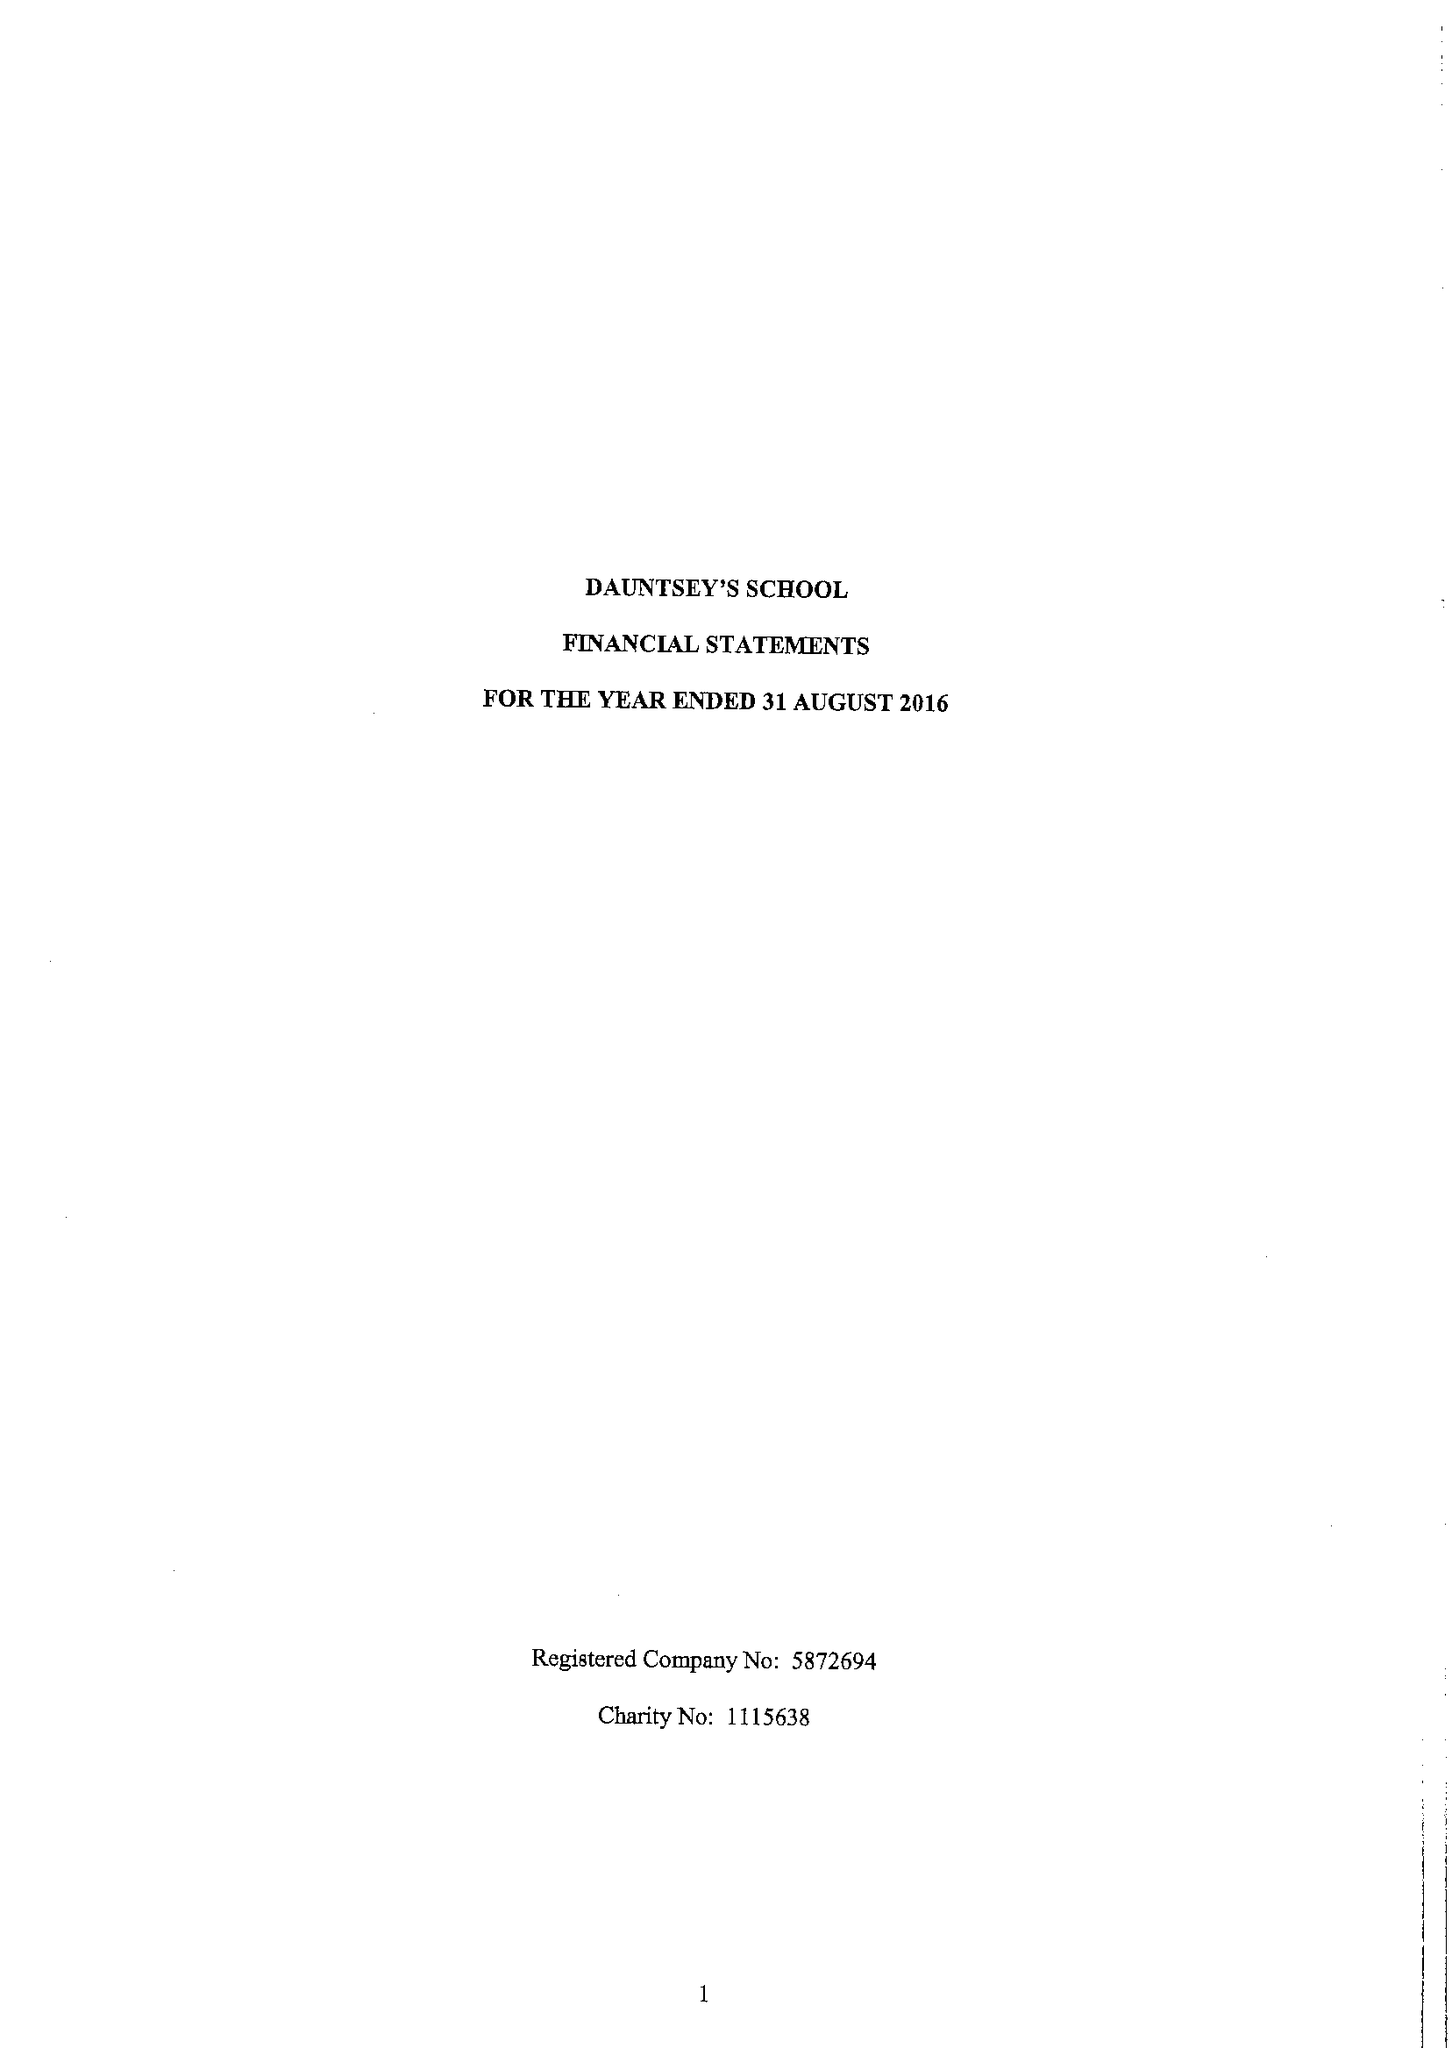What is the value for the address__street_line?
Answer the question using a single word or phrase. HIGH STREET 